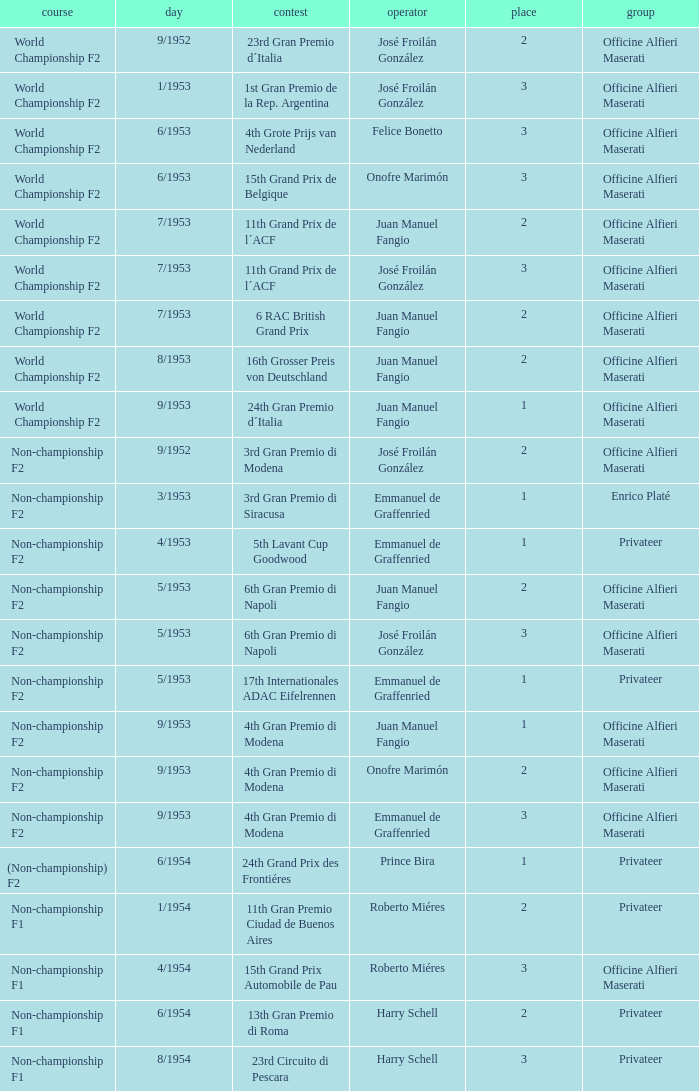What driver has a team of officine alfieri maserati and belongs to the class of non-championship f2 and has a position of 2, as well as a date of 9/1952? José Froilán González. 